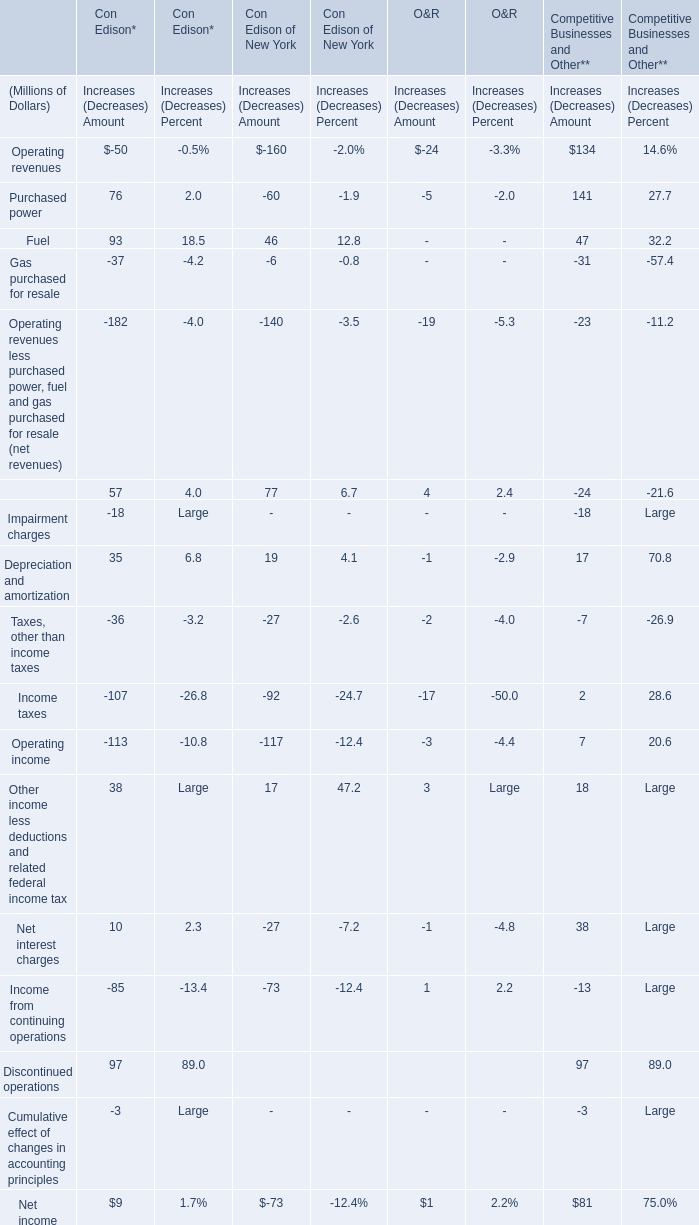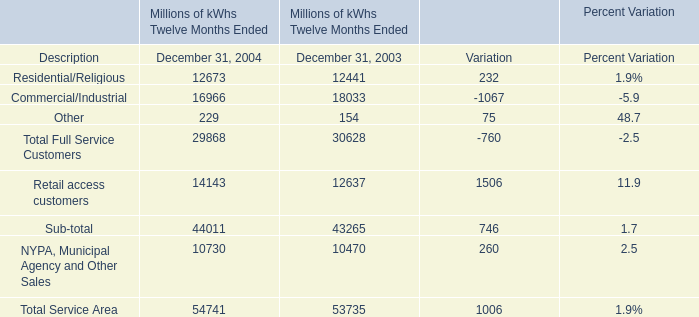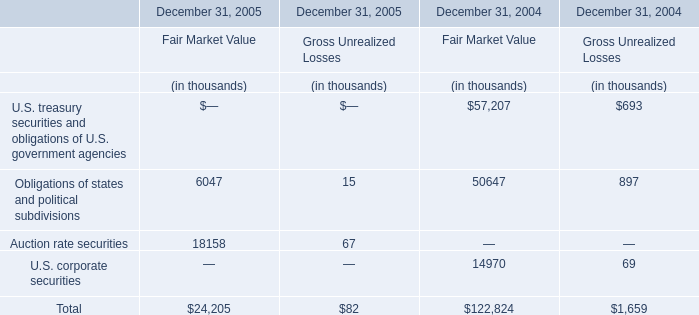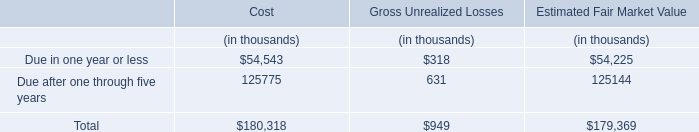Which year is electricity volume of Total Full Service Customers the lowest? 
Answer: 2004. 